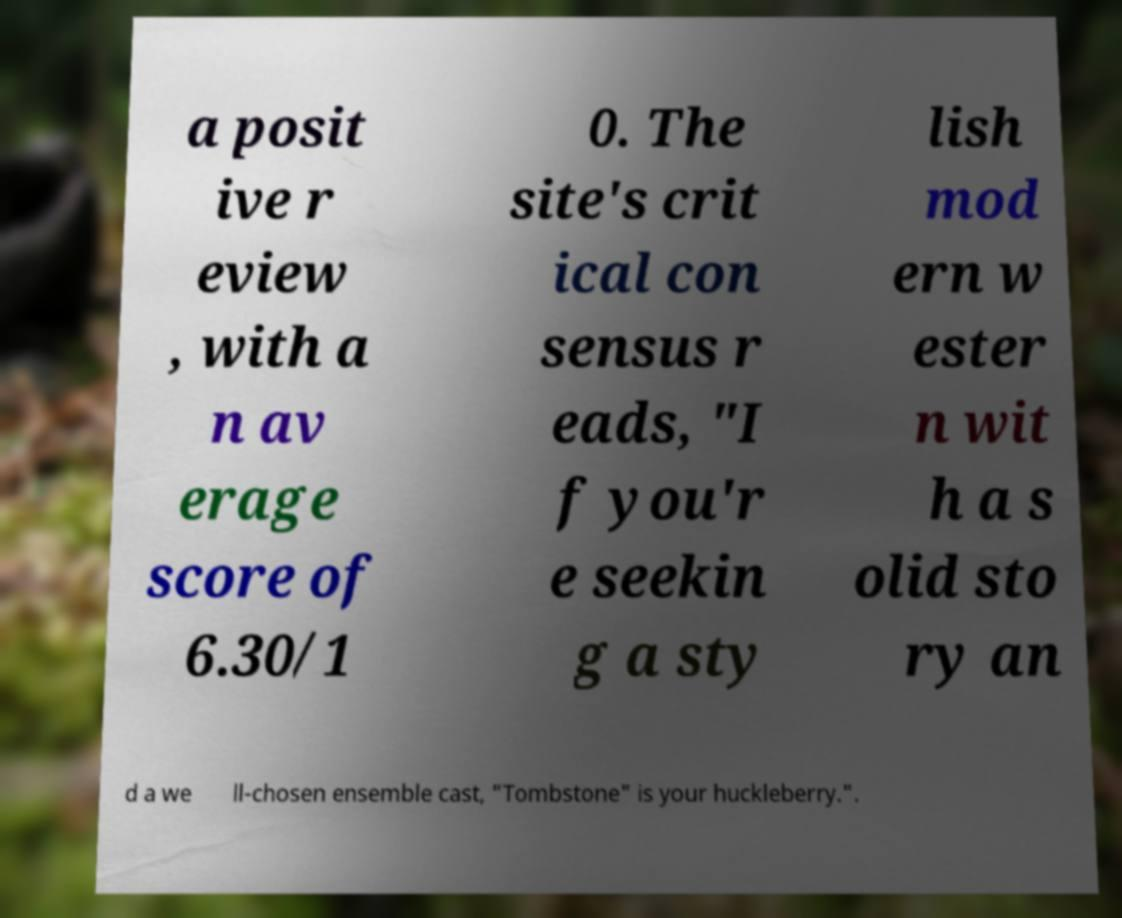Please read and relay the text visible in this image. What does it say? a posit ive r eview , with a n av erage score of 6.30/1 0. The site's crit ical con sensus r eads, "I f you'r e seekin g a sty lish mod ern w ester n wit h a s olid sto ry an d a we ll-chosen ensemble cast, "Tombstone" is your huckleberry.". 